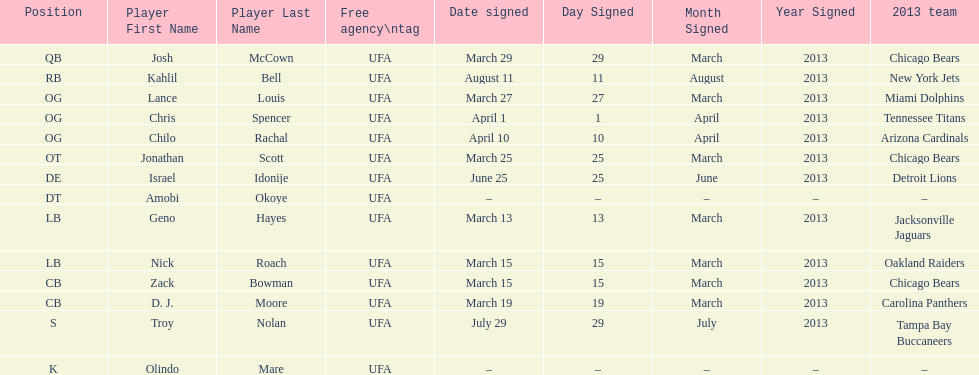Nick roach was signed the same day as what other player? Zack Bowman. 